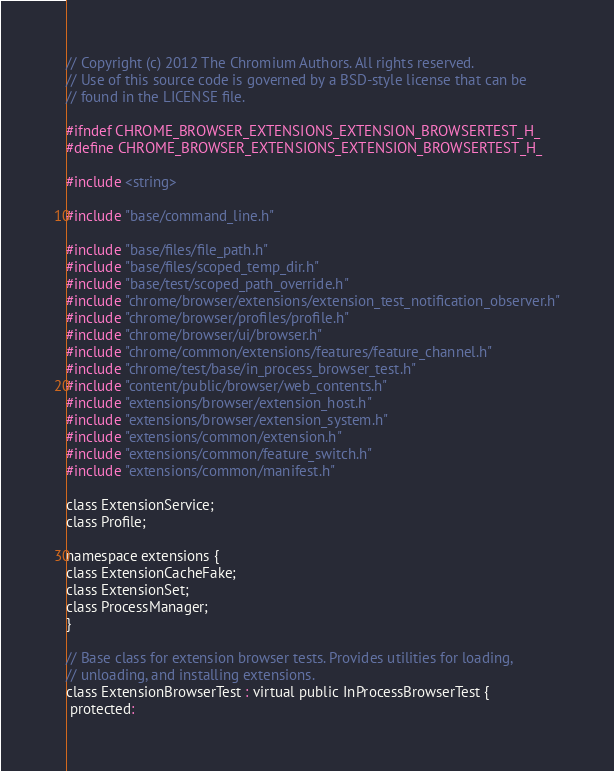<code> <loc_0><loc_0><loc_500><loc_500><_C_>// Copyright (c) 2012 The Chromium Authors. All rights reserved.
// Use of this source code is governed by a BSD-style license that can be
// found in the LICENSE file.

#ifndef CHROME_BROWSER_EXTENSIONS_EXTENSION_BROWSERTEST_H_
#define CHROME_BROWSER_EXTENSIONS_EXTENSION_BROWSERTEST_H_

#include <string>

#include "base/command_line.h"

#include "base/files/file_path.h"
#include "base/files/scoped_temp_dir.h"
#include "base/test/scoped_path_override.h"
#include "chrome/browser/extensions/extension_test_notification_observer.h"
#include "chrome/browser/profiles/profile.h"
#include "chrome/browser/ui/browser.h"
#include "chrome/common/extensions/features/feature_channel.h"
#include "chrome/test/base/in_process_browser_test.h"
#include "content/public/browser/web_contents.h"
#include "extensions/browser/extension_host.h"
#include "extensions/browser/extension_system.h"
#include "extensions/common/extension.h"
#include "extensions/common/feature_switch.h"
#include "extensions/common/manifest.h"

class ExtensionService;
class Profile;

namespace extensions {
class ExtensionCacheFake;
class ExtensionSet;
class ProcessManager;
}

// Base class for extension browser tests. Provides utilities for loading,
// unloading, and installing extensions.
class ExtensionBrowserTest : virtual public InProcessBrowserTest {
 protected:</code> 